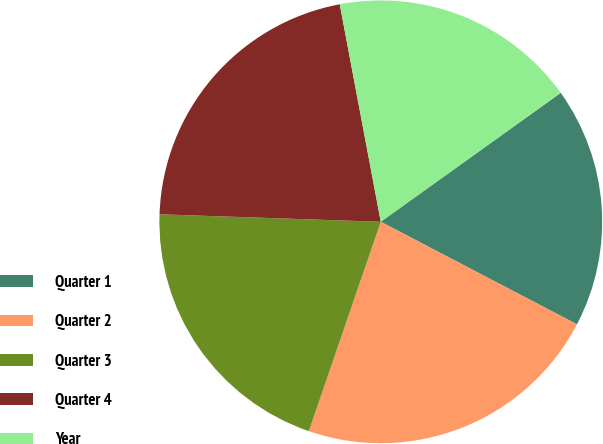Convert chart. <chart><loc_0><loc_0><loc_500><loc_500><pie_chart><fcel>Quarter 1<fcel>Quarter 2<fcel>Quarter 3<fcel>Quarter 4<fcel>Year<nl><fcel>17.56%<fcel>22.6%<fcel>20.27%<fcel>21.49%<fcel>18.07%<nl></chart> 